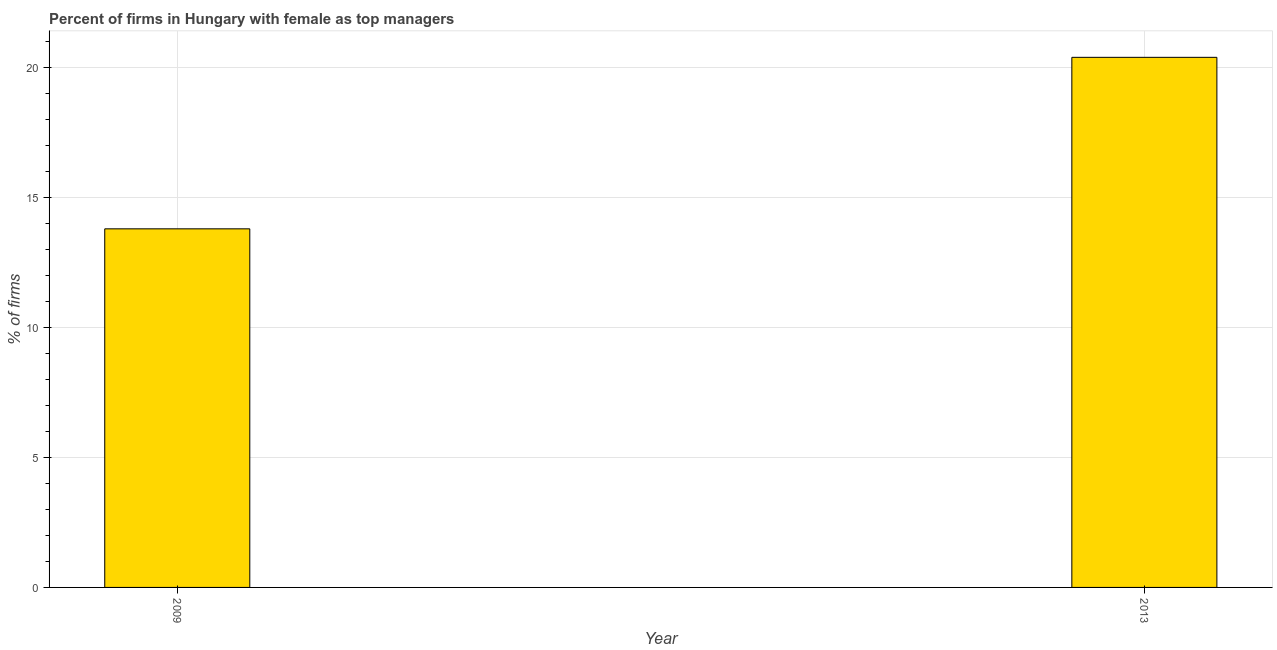Does the graph contain any zero values?
Give a very brief answer. No. What is the title of the graph?
Your response must be concise. Percent of firms in Hungary with female as top managers. What is the label or title of the X-axis?
Your response must be concise. Year. What is the label or title of the Y-axis?
Offer a terse response. % of firms. What is the percentage of firms with female as top manager in 2009?
Keep it short and to the point. 13.8. Across all years, what is the maximum percentage of firms with female as top manager?
Provide a succinct answer. 20.4. Across all years, what is the minimum percentage of firms with female as top manager?
Your answer should be compact. 13.8. In which year was the percentage of firms with female as top manager maximum?
Your answer should be compact. 2013. What is the sum of the percentage of firms with female as top manager?
Make the answer very short. 34.2. In how many years, is the percentage of firms with female as top manager greater than 4 %?
Offer a very short reply. 2. Do a majority of the years between 2009 and 2013 (inclusive) have percentage of firms with female as top manager greater than 2 %?
Provide a short and direct response. Yes. What is the ratio of the percentage of firms with female as top manager in 2009 to that in 2013?
Offer a very short reply. 0.68. Is the percentage of firms with female as top manager in 2009 less than that in 2013?
Your answer should be very brief. Yes. In how many years, is the percentage of firms with female as top manager greater than the average percentage of firms with female as top manager taken over all years?
Offer a terse response. 1. What is the difference between two consecutive major ticks on the Y-axis?
Your response must be concise. 5. What is the % of firms of 2013?
Your answer should be very brief. 20.4. What is the ratio of the % of firms in 2009 to that in 2013?
Your answer should be compact. 0.68. 